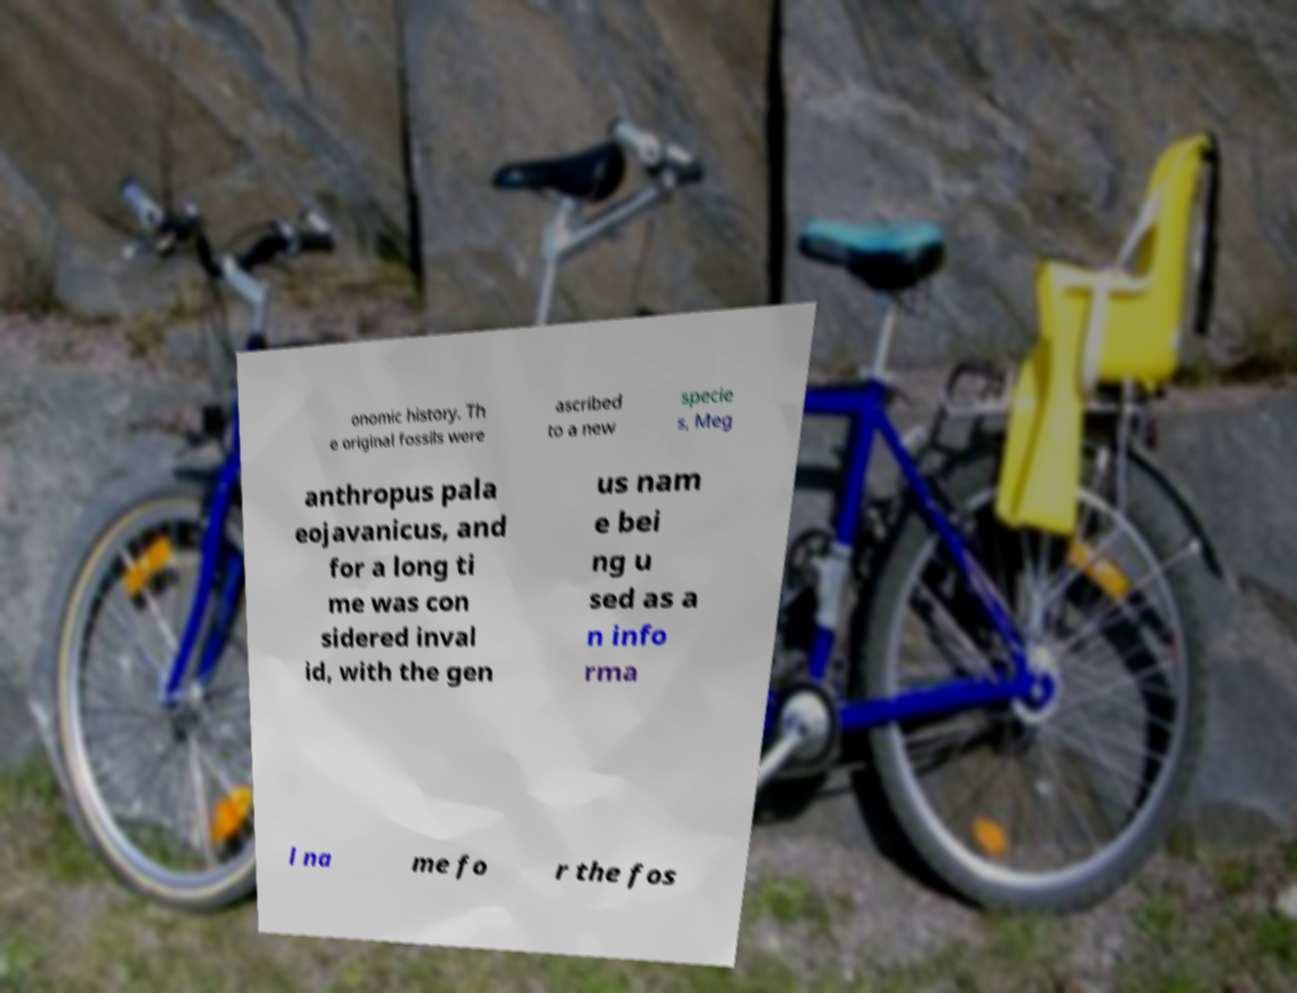Can you read and provide the text displayed in the image?This photo seems to have some interesting text. Can you extract and type it out for me? onomic history. Th e original fossils were ascribed to a new specie s, Meg anthropus pala eojavanicus, and for a long ti me was con sidered inval id, with the gen us nam e bei ng u sed as a n info rma l na me fo r the fos 